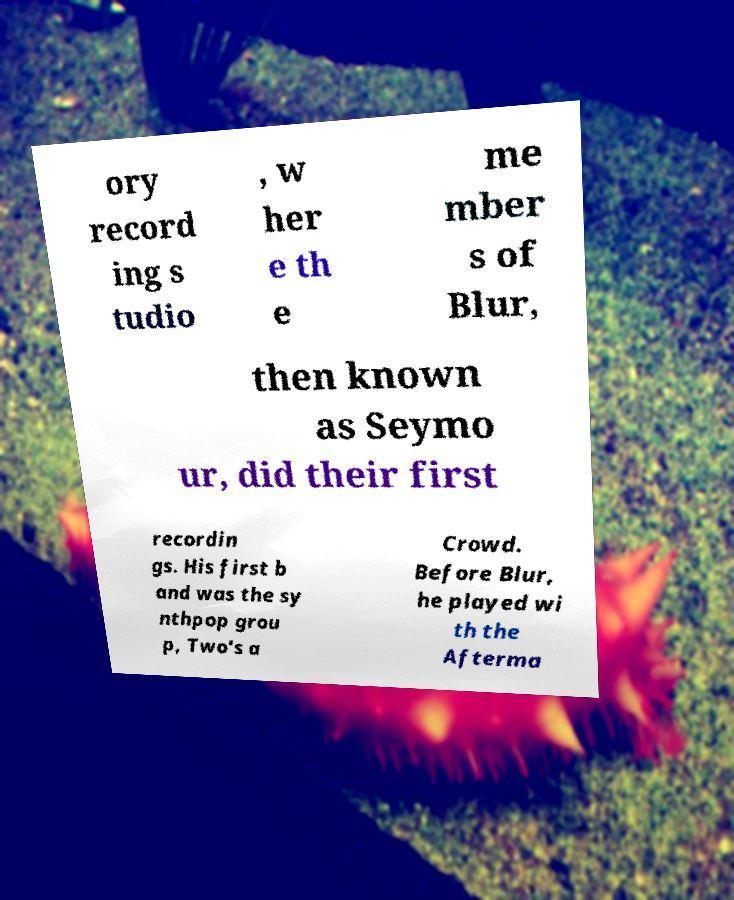Can you read and provide the text displayed in the image?This photo seems to have some interesting text. Can you extract and type it out for me? ory record ing s tudio , w her e th e me mber s of Blur, then known as Seymo ur, did their first recordin gs. His first b and was the sy nthpop grou p, Two's a Crowd. Before Blur, he played wi th the Afterma 